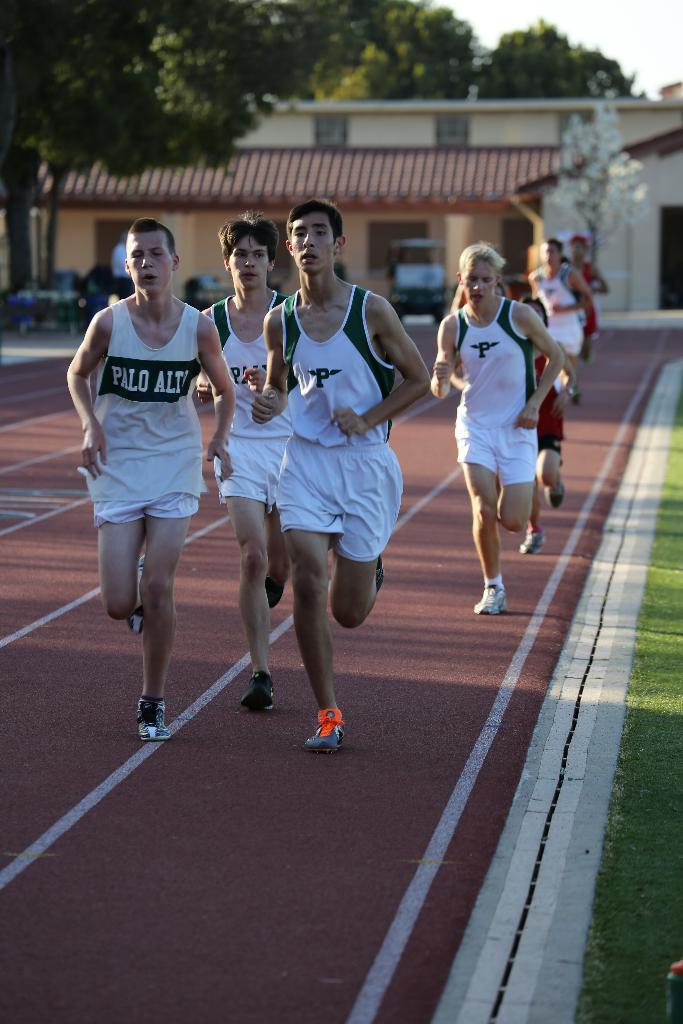How many people are in the image? There are persons in the image, but the exact number is not specified. What are the persons wearing? The persons are wearing clothes. What activity are the persons engaged in? The persons are running on a track. What type of structure can be seen in the image? There is a building in the image. What type of vegetation is present in the image? There are trees in the image. What type of paste is being used by the persons in the image? There is no mention of paste in the image, so it cannot be determined if any paste is being used. 